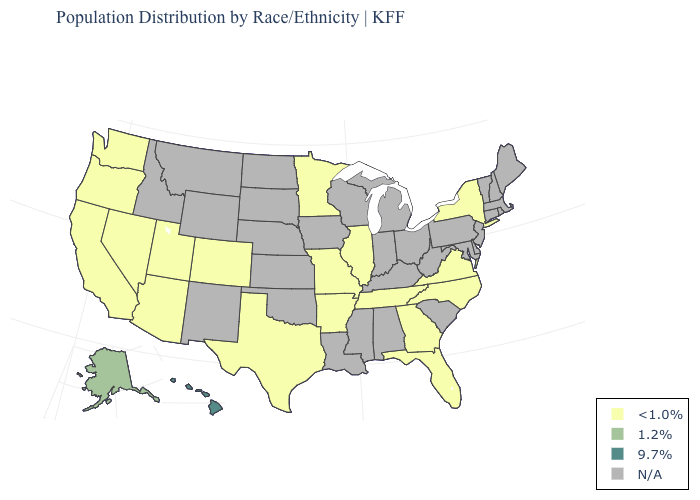What is the value of Maine?
Short answer required. N/A. Name the states that have a value in the range 1.2%?
Give a very brief answer. Alaska. What is the highest value in the USA?
Answer briefly. 9.7%. What is the lowest value in states that border Georgia?
Be succinct. <1.0%. What is the highest value in states that border Wyoming?
Give a very brief answer. <1.0%. Name the states that have a value in the range N/A?
Keep it brief. Alabama, Connecticut, Delaware, Idaho, Indiana, Iowa, Kansas, Kentucky, Louisiana, Maine, Maryland, Massachusetts, Michigan, Mississippi, Montana, Nebraska, New Hampshire, New Jersey, New Mexico, North Dakota, Ohio, Oklahoma, Pennsylvania, Rhode Island, South Carolina, South Dakota, Vermont, West Virginia, Wisconsin, Wyoming. Among the states that border Alabama , which have the lowest value?
Give a very brief answer. Florida, Georgia, Tennessee. Among the states that border Kentucky , which have the highest value?
Concise answer only. Illinois, Missouri, Tennessee, Virginia. What is the value of Kentucky?
Concise answer only. N/A. What is the value of Nevada?
Short answer required. <1.0%. How many symbols are there in the legend?
Be succinct. 4. What is the lowest value in the USA?
Short answer required. <1.0%. Among the states that border North Dakota , which have the highest value?
Quick response, please. Minnesota. 